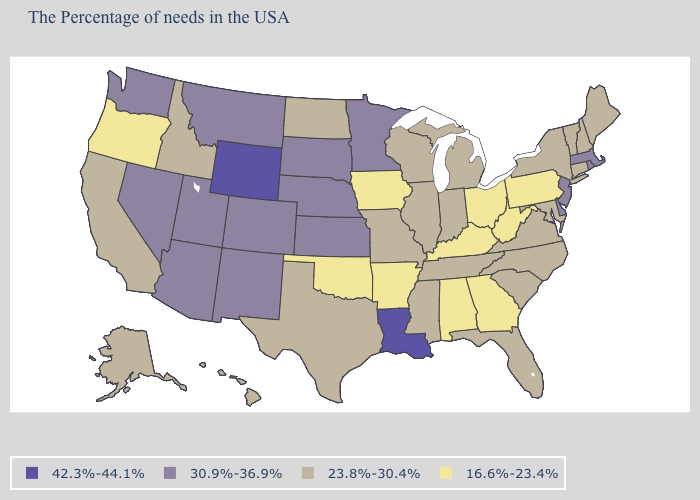Name the states that have a value in the range 42.3%-44.1%?
Write a very short answer. Louisiana, Wyoming. What is the highest value in states that border Oregon?
Keep it brief. 30.9%-36.9%. What is the value of Maryland?
Quick response, please. 23.8%-30.4%. What is the value of Connecticut?
Keep it brief. 23.8%-30.4%. What is the lowest value in states that border Minnesota?
Give a very brief answer. 16.6%-23.4%. Among the states that border Wyoming , does Idaho have the lowest value?
Give a very brief answer. Yes. Name the states that have a value in the range 42.3%-44.1%?
Write a very short answer. Louisiana, Wyoming. What is the value of Rhode Island?
Write a very short answer. 30.9%-36.9%. What is the lowest value in the USA?
Concise answer only. 16.6%-23.4%. Which states have the lowest value in the Northeast?
Short answer required. Pennsylvania. What is the lowest value in the West?
Be succinct. 16.6%-23.4%. Does the first symbol in the legend represent the smallest category?
Write a very short answer. No. Which states hav the highest value in the South?
Give a very brief answer. Louisiana. Is the legend a continuous bar?
Concise answer only. No. Does the first symbol in the legend represent the smallest category?
Quick response, please. No. 